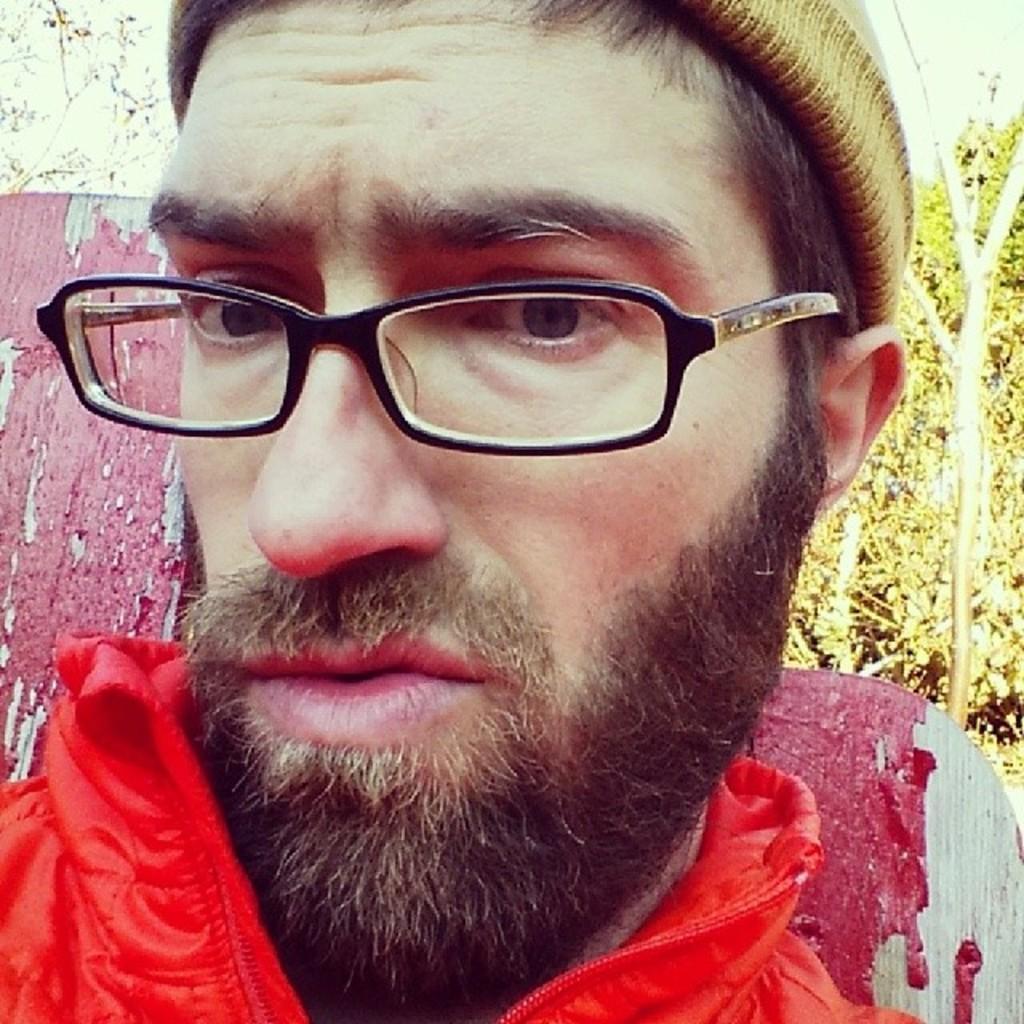Could you give a brief overview of what you see in this image? In this image, I can see the man with beard and mustache. He wore a cap, spectacles and a red jacket. These look like the trees. I think this is the wooden board with a red paint. 